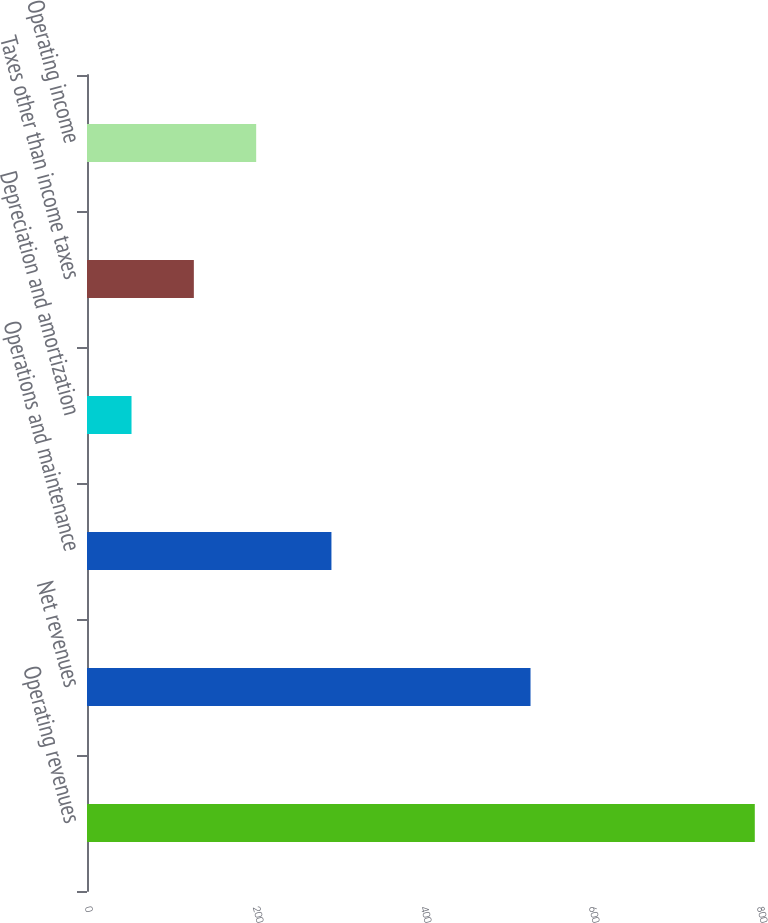Convert chart to OTSL. <chart><loc_0><loc_0><loc_500><loc_500><bar_chart><fcel>Operating revenues<fcel>Net revenues<fcel>Operations and maintenance<fcel>Depreciation and amortization<fcel>Taxes other than income taxes<fcel>Operating income<nl><fcel>795<fcel>528<fcel>291<fcel>53<fcel>127.2<fcel>201.4<nl></chart> 